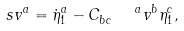<formula> <loc_0><loc_0><loc_500><loc_500>s v ^ { a } = \dot { \eta } _ { 1 } ^ { a } - C _ { b c } ^ { \quad a } v ^ { b } \eta _ { 1 } ^ { c } ,</formula> 